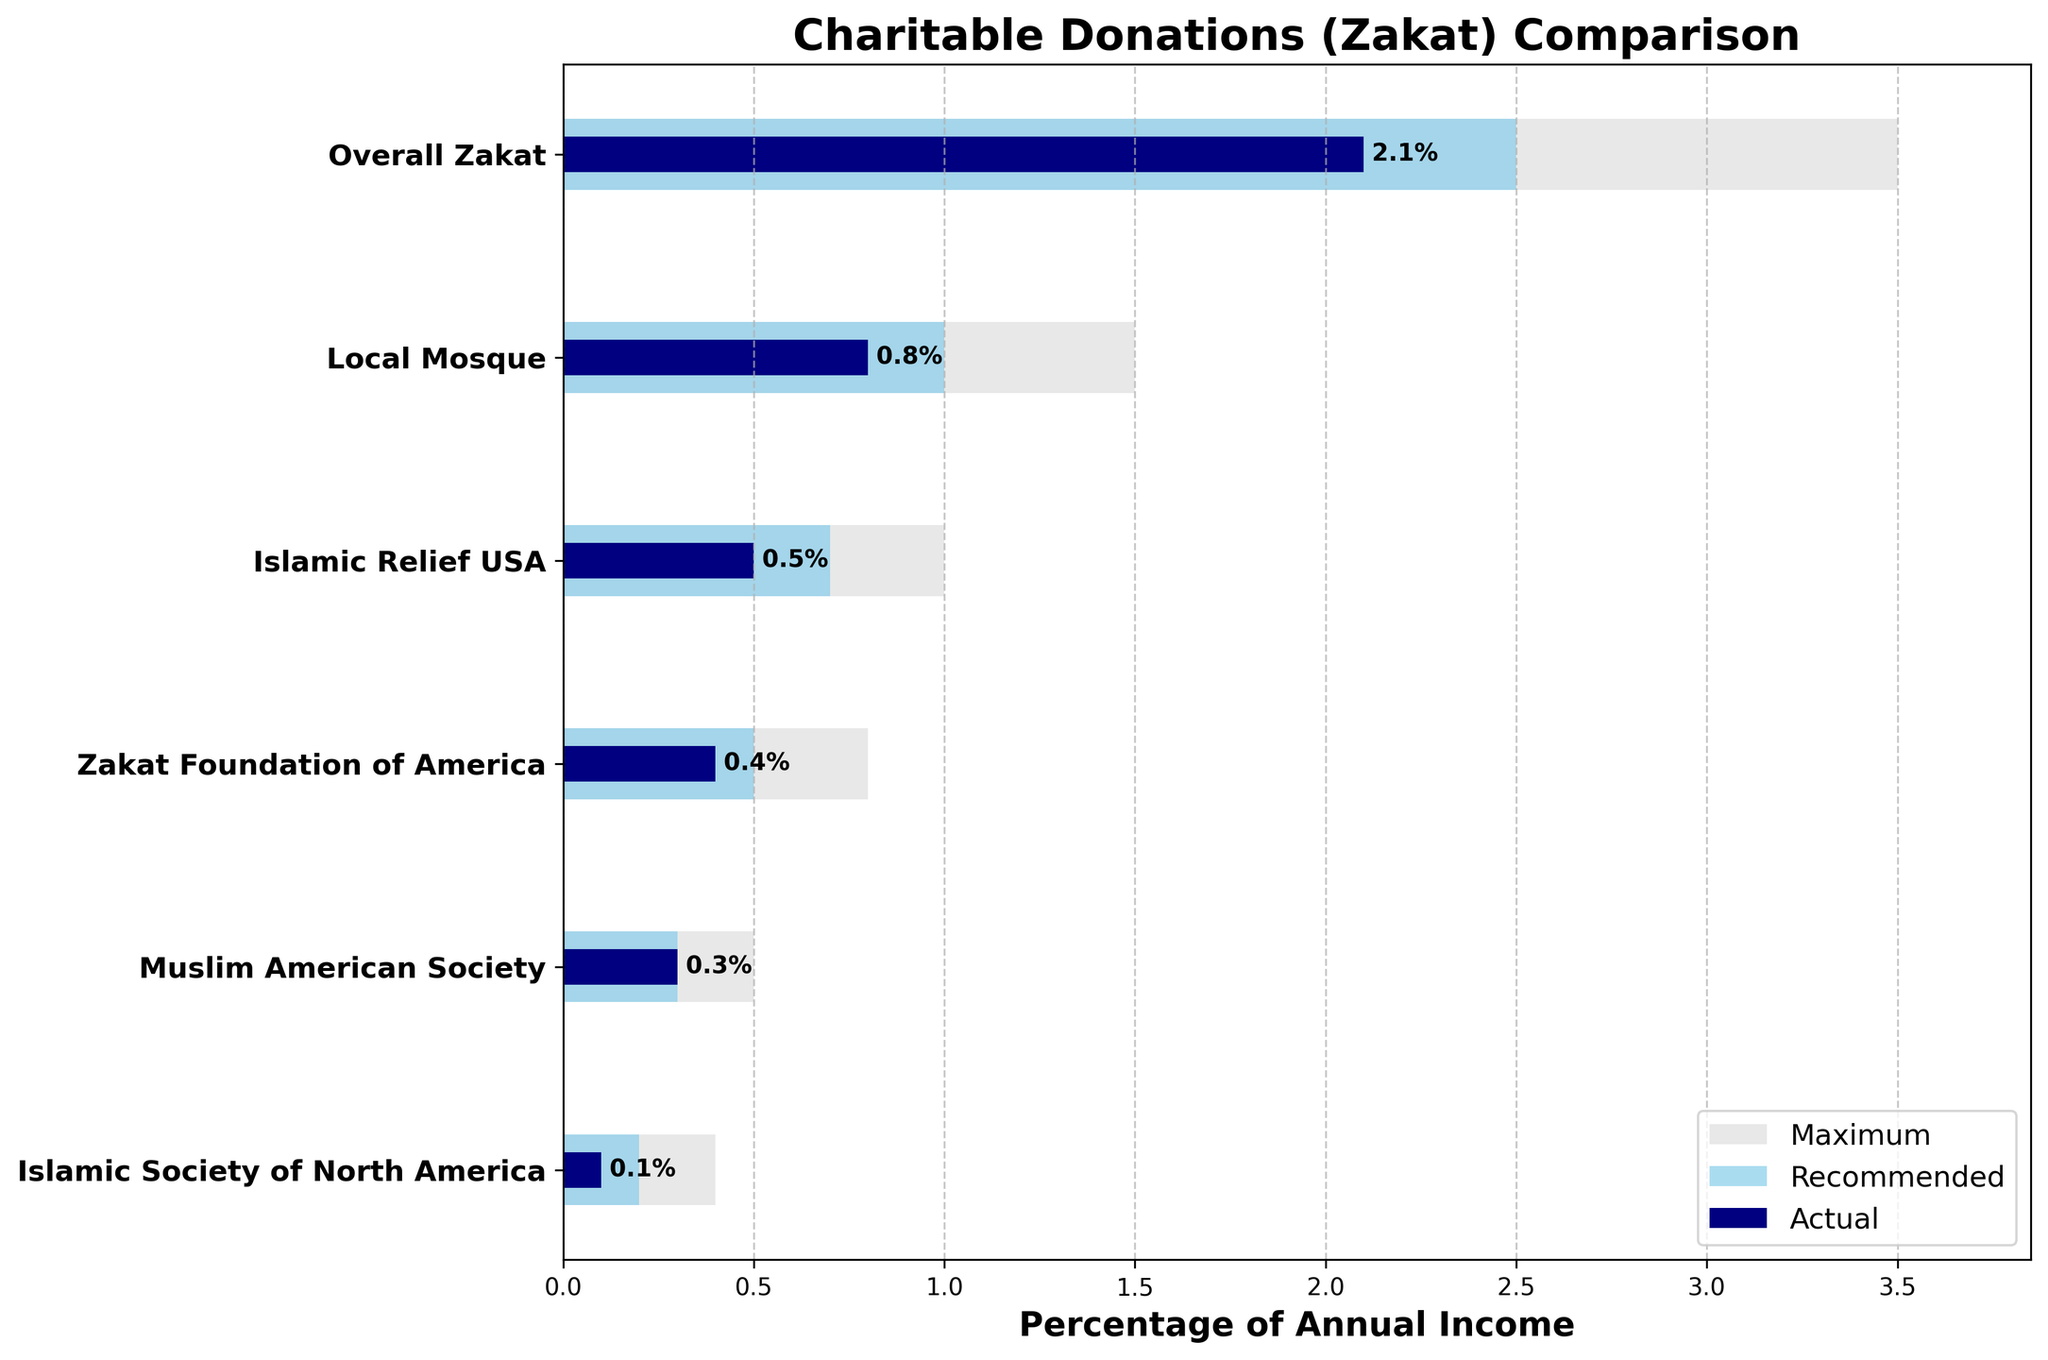What is the percentage of annual income for the 'Local Mosque' category compared to the recommended amount? The 'Local Mosque' category shows an actual percentage of 0.8%, and the recommended amount is 1.0%.
Answer: 0.8% Which category has the highest actual percentage of annual income? By looking at the bars representing actual values, the 'Overall Zakat' category has the highest actual percentage at 2.1%.
Answer: Overall Zakat What is the difference between the actual and maximum percentage for the 'Islamic Society of North America'? The actual percentage for 'Islamic Society of North America' is 0.1%, and the maximum is 0.4%. The difference is 0.3% (0.4% - 0.1%).
Answer: 0.3% For which categories do the actual percentages meet or exceed the recommended percentage? We examine each category to find whether the actual percentage is greater than or equal to the recommended percentage. Here, 'Muslim American Society' has an actual percentage of 0.3%, which meets the recommended percentage of 0.3%.
Answer: Muslim American Society What is the sum of the actual percentages for all categories? By adding up all the actual percentages: 2.1% (Overall Zakat) + 0.8% (Local Mosque) + 0.5% (Islamic Relief USA) + 0.4% (Zakat Foundation of America) + 0.3% (Muslim American Society) + 0.1% (Islamic Society of North America), the total is 4.2%.
Answer: 4.2% Which category has the smallest margin between its actual and recommended percentages? We calculate the margin for each category: Overall Zakat (2.1% - 2.5% = -0.4%), Local Mosque (0.8% - 1.0% = -0.2%), Islamic Relief USA (0.5% - 0.7% = -0.2%), Zakat Foundation of America (0.4% - 0.5% = -0.1%), Muslim American Society (0.3% - 0.3% = 0%), Islamic Society of North America (0.1% - 0.2% = -0.1%). The smallest non-negative margin is 0% for Muslim American Society.
Answer: Muslim American Society How does the actual percentage for 'Islamic Relief USA' compare to its recommended and maximum percentages? The 'Islamic Relief USA' has an actual percentage of 0.5%, a recommended percentage of 0.7%, and a maximum percentage of 1.0%. The actual percentage is lower than both the recommended and maximum percentages.
Answer: Lower than both What percentage of the maximum does 'Zakat Foundation of America' achieve? The actual percentage for 'Zakat Foundation of America' is 0.4%, and the maximum percentage is 0.8%. To find the proportion: (0.4 / 0.8) * 100% = 50%.
Answer: 50% Which category shows the largest deviation from its maximum percentage? By comparing the deviations: Overall Zakat (3.5% - 2.1% = 1.4%), Local Mosque (1.5% - 0.8% = 0.7%), Islamic Relief USA (1.0% - 0.5% = 0.5%), Zakat Foundation of America (0.8% - 0.4% = 0.4%), Muslim American Society (0.5% - 0.3% = 0.2%), Islamic Society of North America (0.4% - 0.1% = 0.3%), Overall Zakat has the largest deviation of 1.4%.
Answer: Overall Zakat 